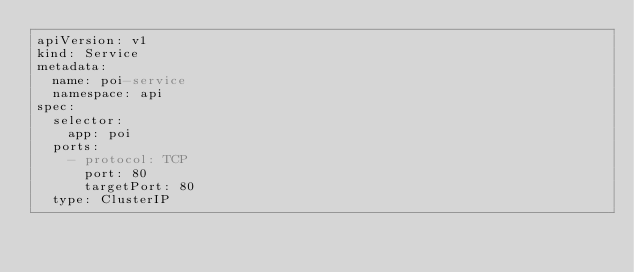Convert code to text. <code><loc_0><loc_0><loc_500><loc_500><_YAML_>apiVersion: v1
kind: Service
metadata:
  name: poi-service
  namespace: api
spec:
  selector:
    app: poi
  ports:
    - protocol: TCP
      port: 80
      targetPort: 80
  type: ClusterIP</code> 